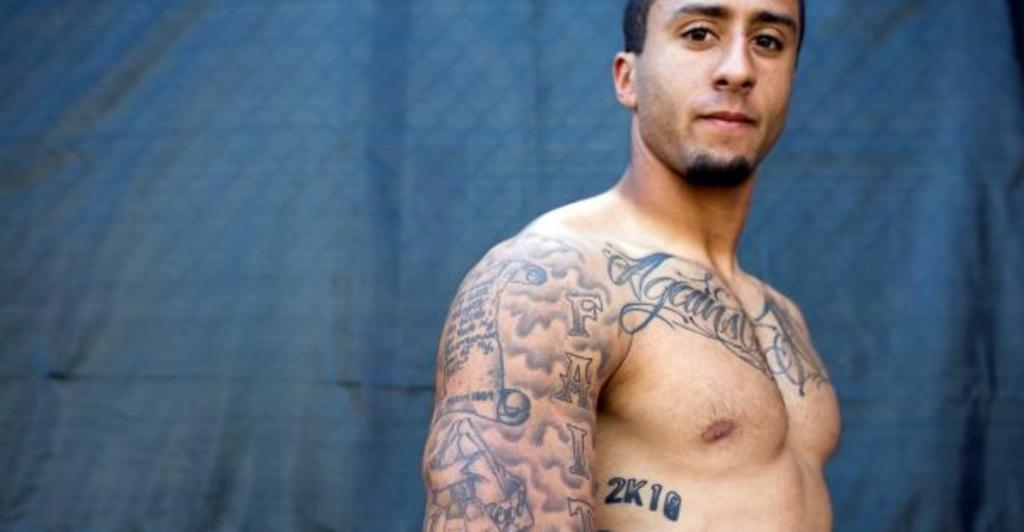What is the main subject of the image? There is a man standing in the image. Can you describe any distinguishing features of the man? The man has a tattoo on his body. What color can be seen in the background of the image? There is a blue color cover in the background of the image. How many minutes does the man spend in prison in the image? There is no indication of the man being in prison or spending any minutes in prison in the image. 